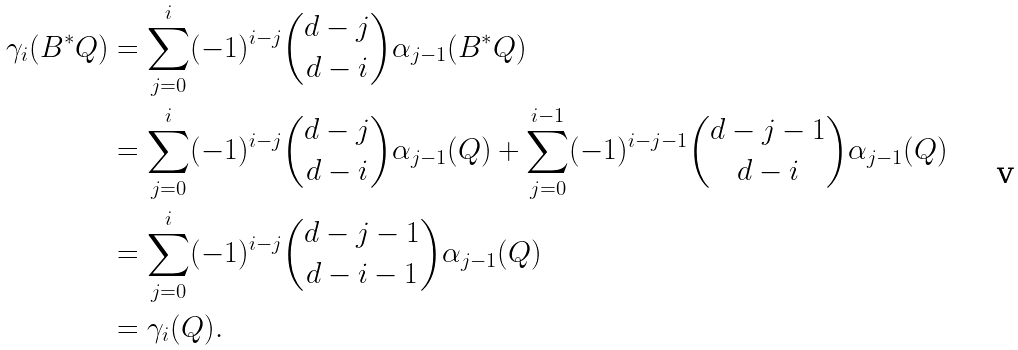Convert formula to latex. <formula><loc_0><loc_0><loc_500><loc_500>\gamma _ { i } ( B ^ { * } Q ) & = \sum _ { j = 0 } ^ { i } ( - 1 ) ^ { i - j } { d - j \choose d - i } \alpha _ { j - 1 } ( B ^ { * } Q ) \\ & = \sum _ { j = 0 } ^ { i } ( - 1 ) ^ { i - j } { d - j \choose d - i } \alpha _ { j - 1 } ( Q ) + \sum _ { j = 0 } ^ { i - 1 } ( - 1 ) ^ { i - j - 1 } { d - j - 1 \choose d - i } \alpha _ { j - 1 } ( Q ) \\ & = \sum _ { j = 0 } ^ { i } ( - 1 ) ^ { i - j } { d - j - 1 \choose d - i - 1 } \alpha _ { j - 1 } ( Q ) \\ & = \gamma _ { i } ( Q ) .</formula> 